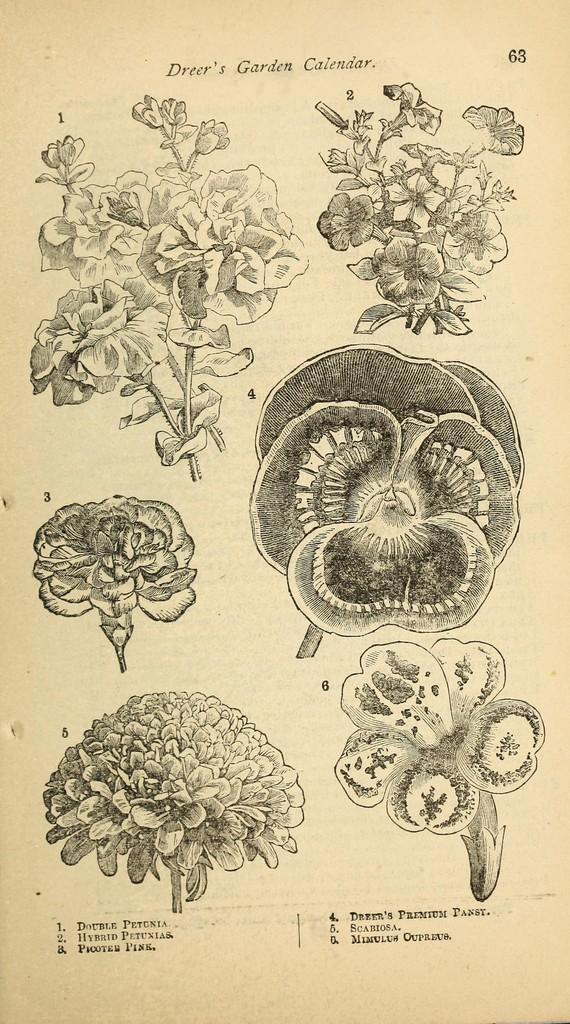What is the main subject of the image? The main subject of the image is many flowers. Are there any other objects or items in the image besides the flowers? Yes, there is a paper with writing on it in the image. Can you describe the appearance of the paper? The paper has black and cream colors. What type of pet can be seen playing with a match in the image? There is no pet or match present in the image; it features many flowers and a paper with writing on it. 